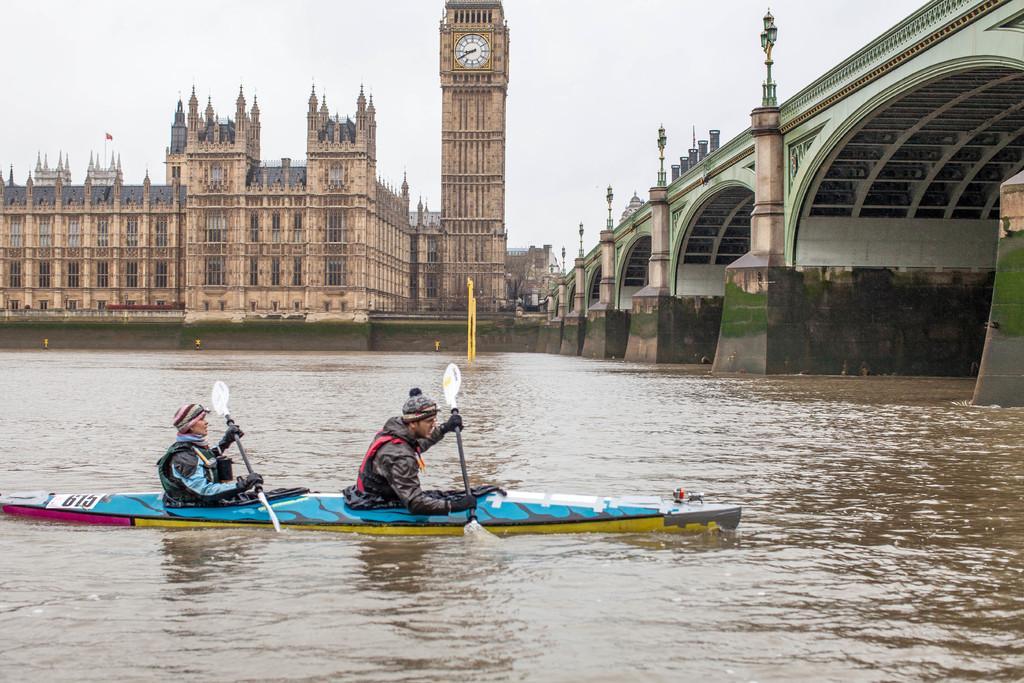How would you summarize this image in a sentence or two? In this image there are two persons sitting in the boat and rowing with the sticks. On the right side there is a bridge. At the bottom there is water. In the background it looks like a palace. Beside the palace there is a tower to which there is a wall clock. At the top there is the sky. There are lights on the bridge. The two persons are wearing the caps and jackets. 